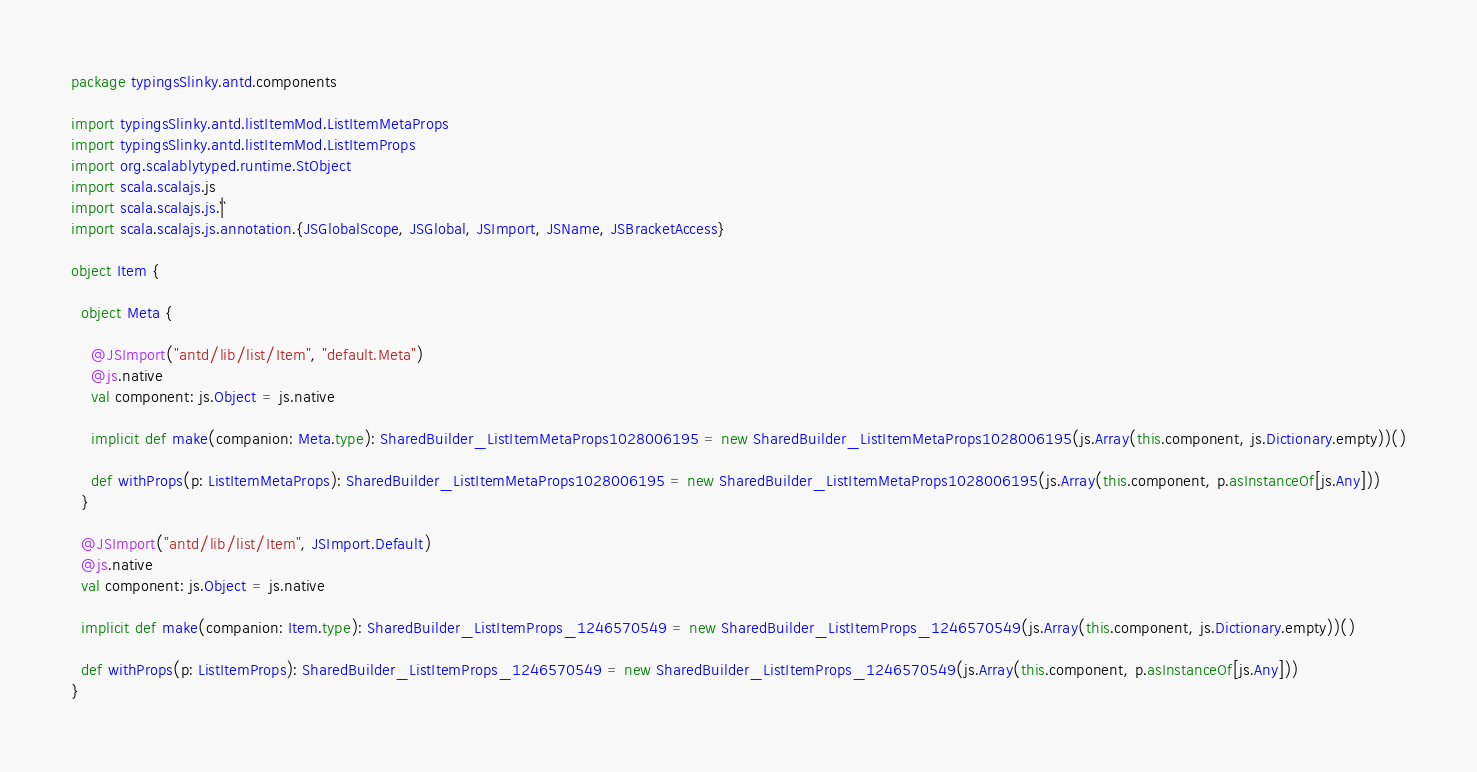<code> <loc_0><loc_0><loc_500><loc_500><_Scala_>package typingsSlinky.antd.components

import typingsSlinky.antd.listItemMod.ListItemMetaProps
import typingsSlinky.antd.listItemMod.ListItemProps
import org.scalablytyped.runtime.StObject
import scala.scalajs.js
import scala.scalajs.js.`|`
import scala.scalajs.js.annotation.{JSGlobalScope, JSGlobal, JSImport, JSName, JSBracketAccess}

object Item {
  
  object Meta {
    
    @JSImport("antd/lib/list/Item", "default.Meta")
    @js.native
    val component: js.Object = js.native
    
    implicit def make(companion: Meta.type): SharedBuilder_ListItemMetaProps1028006195 = new SharedBuilder_ListItemMetaProps1028006195(js.Array(this.component, js.Dictionary.empty))()
    
    def withProps(p: ListItemMetaProps): SharedBuilder_ListItemMetaProps1028006195 = new SharedBuilder_ListItemMetaProps1028006195(js.Array(this.component, p.asInstanceOf[js.Any]))
  }
  
  @JSImport("antd/lib/list/Item", JSImport.Default)
  @js.native
  val component: js.Object = js.native
  
  implicit def make(companion: Item.type): SharedBuilder_ListItemProps_1246570549 = new SharedBuilder_ListItemProps_1246570549(js.Array(this.component, js.Dictionary.empty))()
  
  def withProps(p: ListItemProps): SharedBuilder_ListItemProps_1246570549 = new SharedBuilder_ListItemProps_1246570549(js.Array(this.component, p.asInstanceOf[js.Any]))
}
</code> 